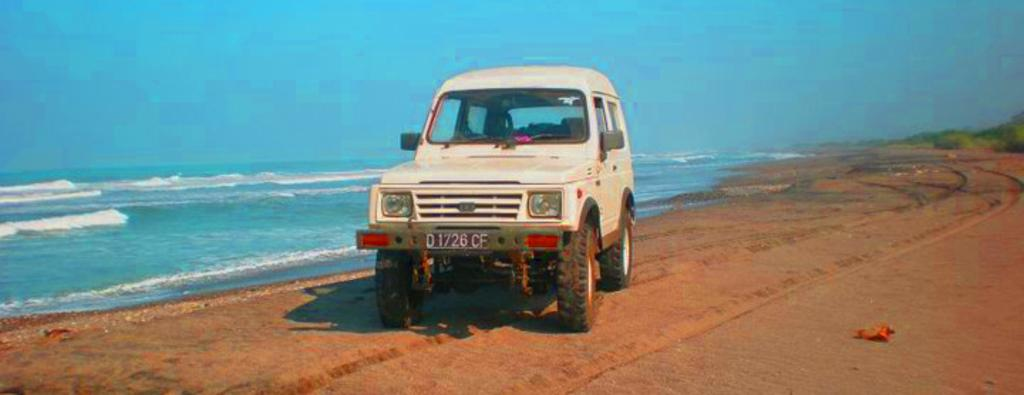What is the color of the vehicle in the image? The vehicle in the image is white. What type of natural elements can be seen in the image? There are trees and water visible in the image. What is the color of the sky in the image? The sky is blue in color. What type of pleasure can be seen enjoying a loaf of bread in the image? There is no person or animal enjoying a loaf of bread in the image; it does not contain any references to pleasure or bread. 